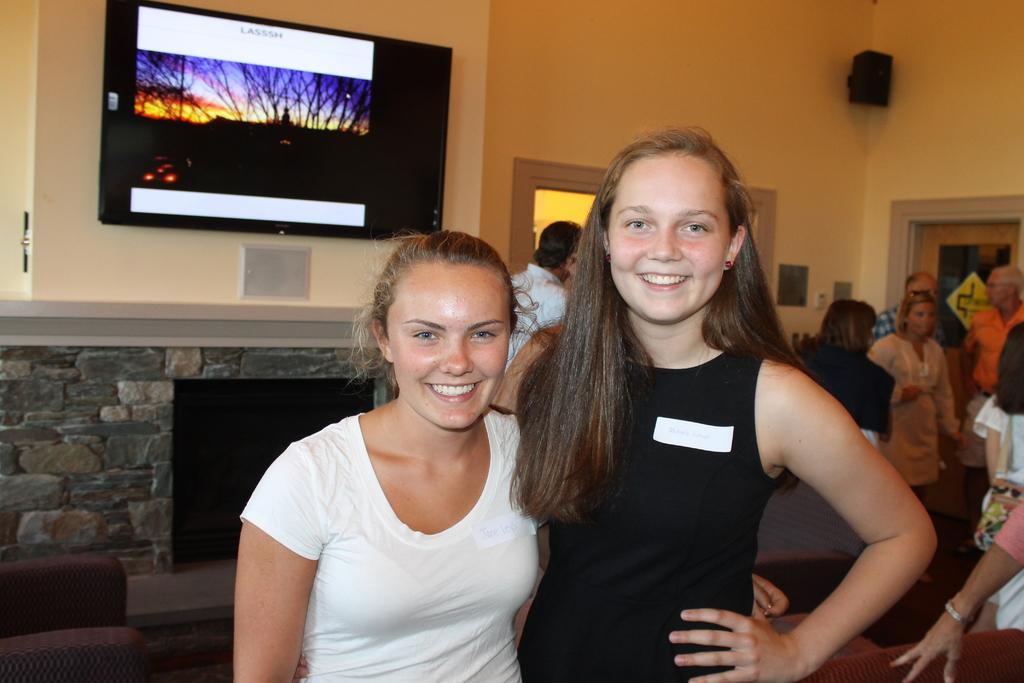In one or two sentences, can you explain what this image depicts? In this picture there are people, among them there are two women standing and smiling and we can see chairs. In the background of the image we can see television on the wall, door and speaker. 